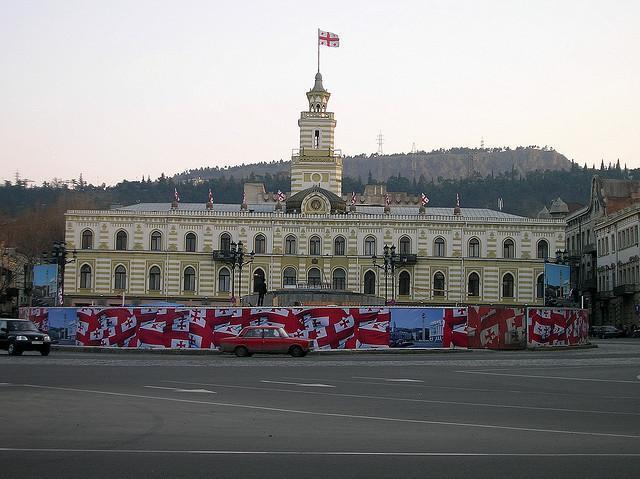This country has what type of government?
Pick the right solution, then justify: 'Answer: answer
Rationale: rationale.'
Options: Republic, monarchy, anarchy, dictatorship. Answer: republic.
Rationale: The country has a republic. 